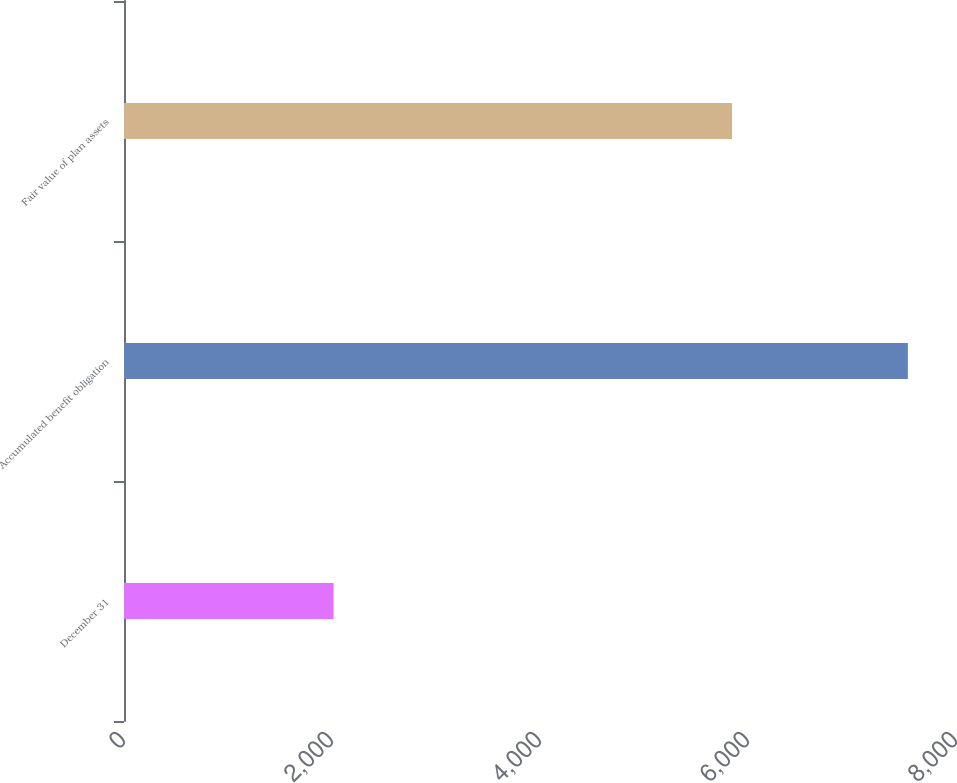Convert chart to OTSL. <chart><loc_0><loc_0><loc_500><loc_500><bar_chart><fcel>December 31<fcel>Accumulated benefit obligation<fcel>Fair value of plan assets<nl><fcel>2015<fcel>7537<fcel>5846<nl></chart> 